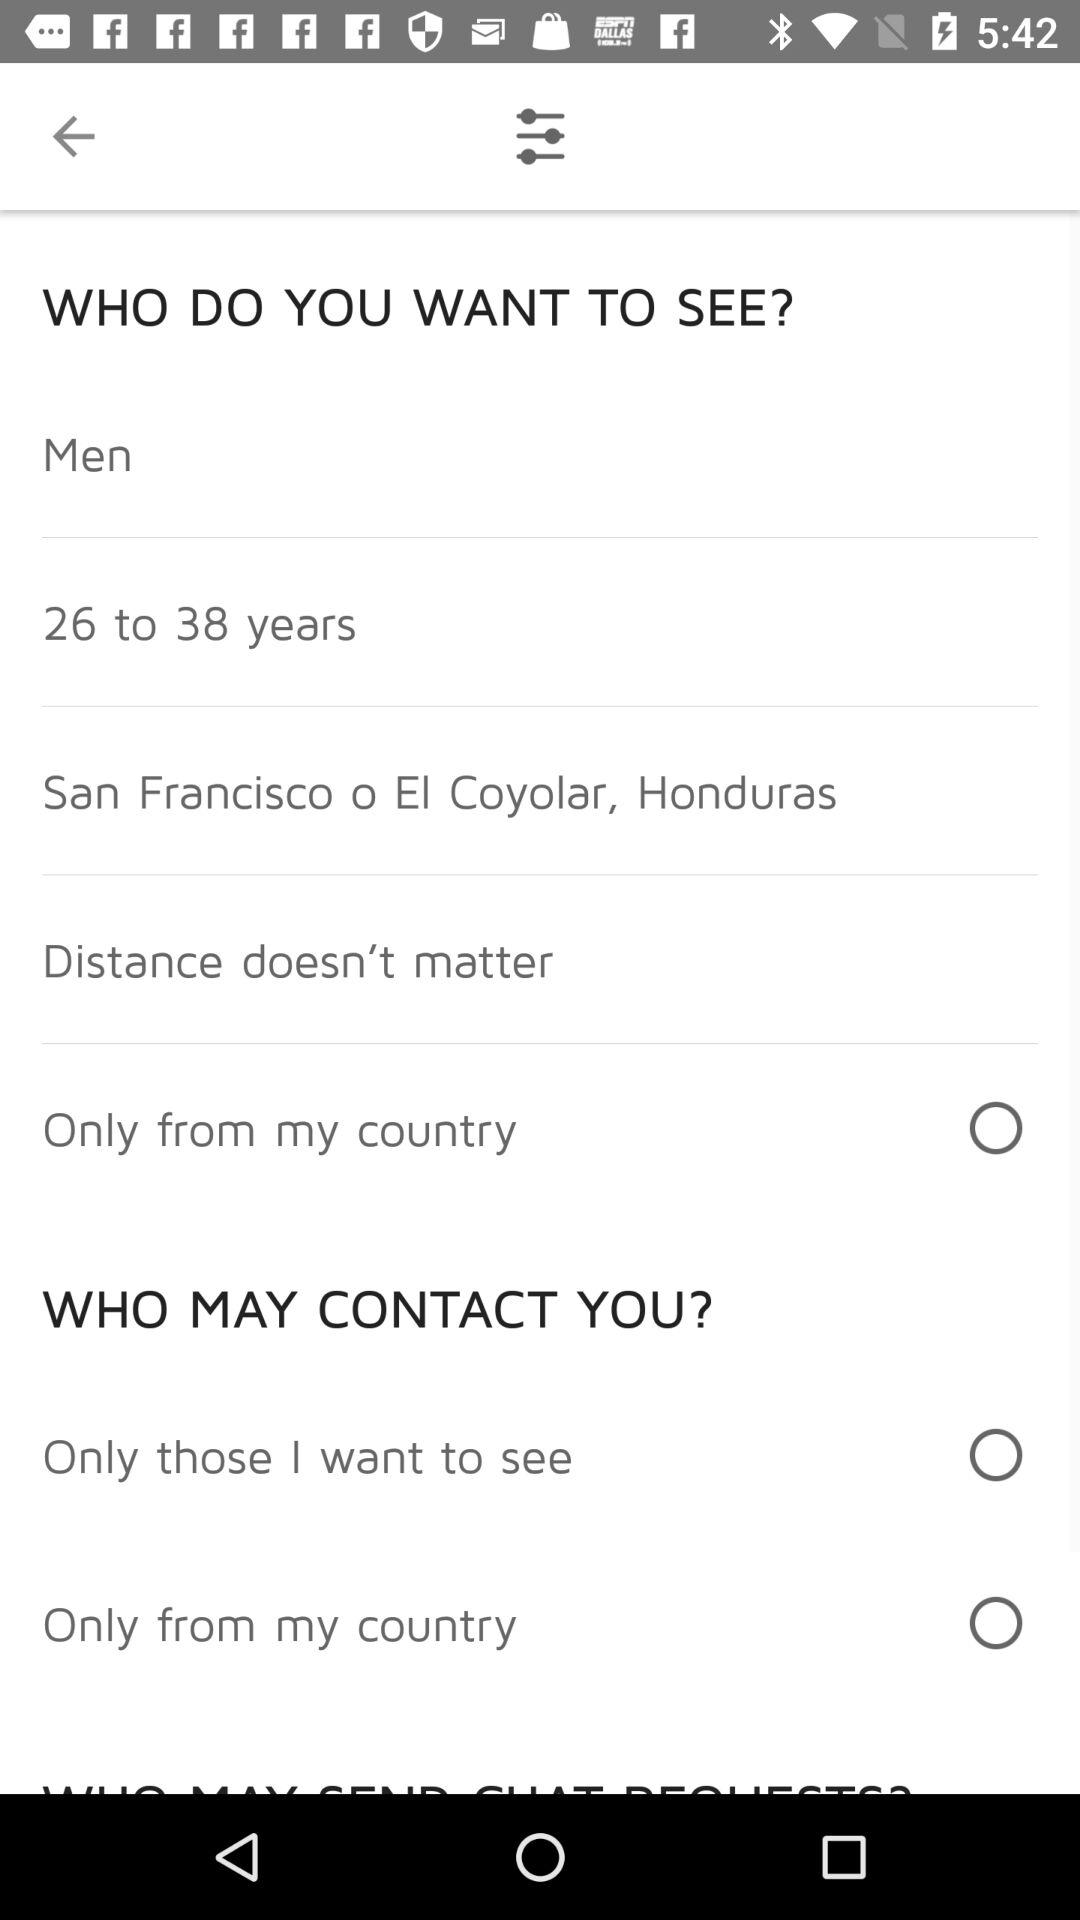What is the age range of men? The age range is between 26 and 38 years. 